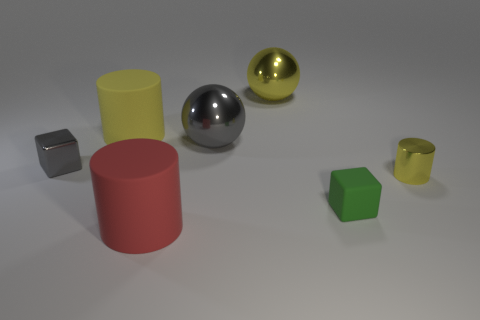Add 1 large gray objects. How many objects exist? 8 Subtract all spheres. How many objects are left? 5 Add 7 tiny green objects. How many tiny green objects exist? 8 Subtract 1 gray balls. How many objects are left? 6 Subtract all big shiny things. Subtract all matte things. How many objects are left? 2 Add 4 green blocks. How many green blocks are left? 5 